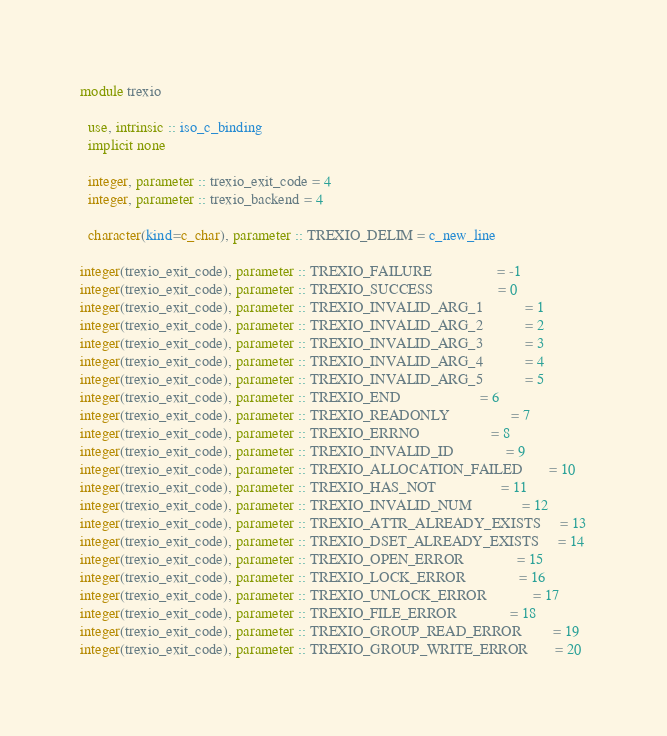<code> <loc_0><loc_0><loc_500><loc_500><_FORTRAN_>module trexio

  use, intrinsic :: iso_c_binding
  implicit none

  integer, parameter :: trexio_exit_code = 4
  integer, parameter :: trexio_backend = 4

  character(kind=c_char), parameter :: TREXIO_DELIM = c_new_line

integer(trexio_exit_code), parameter :: TREXIO_FAILURE                 = -1
integer(trexio_exit_code), parameter :: TREXIO_SUCCESS                 = 0
integer(trexio_exit_code), parameter :: TREXIO_INVALID_ARG_1           = 1
integer(trexio_exit_code), parameter :: TREXIO_INVALID_ARG_2           = 2
integer(trexio_exit_code), parameter :: TREXIO_INVALID_ARG_3           = 3
integer(trexio_exit_code), parameter :: TREXIO_INVALID_ARG_4           = 4
integer(trexio_exit_code), parameter :: TREXIO_INVALID_ARG_5           = 5
integer(trexio_exit_code), parameter :: TREXIO_END                     = 6
integer(trexio_exit_code), parameter :: TREXIO_READONLY                = 7
integer(trexio_exit_code), parameter :: TREXIO_ERRNO                   = 8
integer(trexio_exit_code), parameter :: TREXIO_INVALID_ID              = 9
integer(trexio_exit_code), parameter :: TREXIO_ALLOCATION_FAILED       = 10
integer(trexio_exit_code), parameter :: TREXIO_HAS_NOT                 = 11
integer(trexio_exit_code), parameter :: TREXIO_INVALID_NUM             = 12
integer(trexio_exit_code), parameter :: TREXIO_ATTR_ALREADY_EXISTS     = 13
integer(trexio_exit_code), parameter :: TREXIO_DSET_ALREADY_EXISTS     = 14
integer(trexio_exit_code), parameter :: TREXIO_OPEN_ERROR              = 15
integer(trexio_exit_code), parameter :: TREXIO_LOCK_ERROR              = 16
integer(trexio_exit_code), parameter :: TREXIO_UNLOCK_ERROR            = 17
integer(trexio_exit_code), parameter :: TREXIO_FILE_ERROR              = 18
integer(trexio_exit_code), parameter :: TREXIO_GROUP_READ_ERROR        = 19
integer(trexio_exit_code), parameter :: TREXIO_GROUP_WRITE_ERROR       = 20</code> 